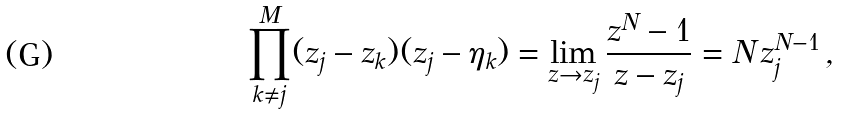Convert formula to latex. <formula><loc_0><loc_0><loc_500><loc_500>\prod _ { k \neq j } ^ { M } ( z _ { j } - z _ { k } ) ( z _ { j } - \eta _ { k } ) = \lim _ { z \rightarrow z _ { j } } \frac { z ^ { N } - 1 } { z - z _ { j } } = N \, z _ { j } ^ { N - 1 } \, ,</formula> 